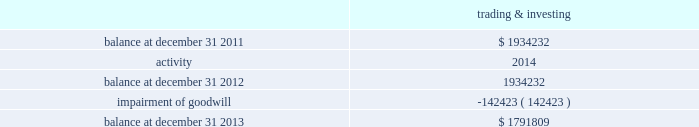Note 9 2014goodwill and other intangibles , net goodwill the table outlines the activity in the carrying value of the company 2019s goodwill , which is all assigned to the company 2019s trading and investing segment ( dollars in thousands ) : .
Goodwill is evaluated for impairment on an annual basis and when events or changes indicate the carrying value of an asset exceeds its fair value and the loss may not be recoverable .
At december 31 , 2013 and 2012 , the company 2019s trading and investing segment had two reporting units ; market making and retail brokerage .
At the end of june 2013 , the company decided to exit its market making business .
Based on this decision in the second quarter of 2013 , the company conducted an interim goodwill impairment test for the market making reporting unit , using the expected sale structure of the market making business .
This structure assumed a shorter period of cash flows related to an order flow arrangement , compared to prior estimates of fair value .
Based on the results of the first step of the goodwill impairment test , the company determined that the carrying value of the market making reporting unit , including goodwill , exceeded the fair value for that reporting unit as of june 30 , 2013 .
The company proceeded to the second step of the goodwill impairment test to measure the amount of goodwill impairment .
As a result of the evaluation , it was determined that the entire carrying amount of goodwill allocated to the market making reporting unit was impaired , and the company recognized a $ 142.4 million impairment of goodwill during the second quarter of 2013 .
For the year ended december 31 , 2013 , the company performed its annual goodwill assessment for the retail brokerage reporting unit , electing to qualitatively assess whether it was more likely than not that the fair value was less than the carrying value .
As a result of this assessment , the company determined that the first step of the goodwill impairment test was not necessary , and concluded that goodwill was not impaired at december 31 , 2013 .
At december 31 , 2013 , goodwill is net of accumulated impairment losses of $ 142.4 million related to the trading and investing segment and $ 101.2 million in the balance sheet management segment .
At december 31 , 2012 , goodwill is net of accumulated impairment losses of $ 101.2 million in the balance sheet management segment. .
What was the percent of the impairment of goodwill to the total goodwill balance at december 31 2013 \\n? 
Rationale: the impairment of goodwill was 7.95% of the total goodwill balance at december 31 2012 \\n
Computations: (142423 / 1791809)
Answer: 0.07949. 